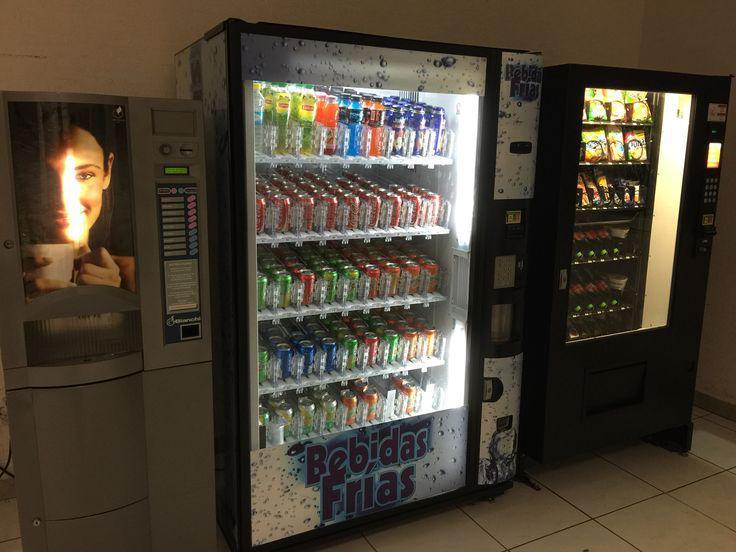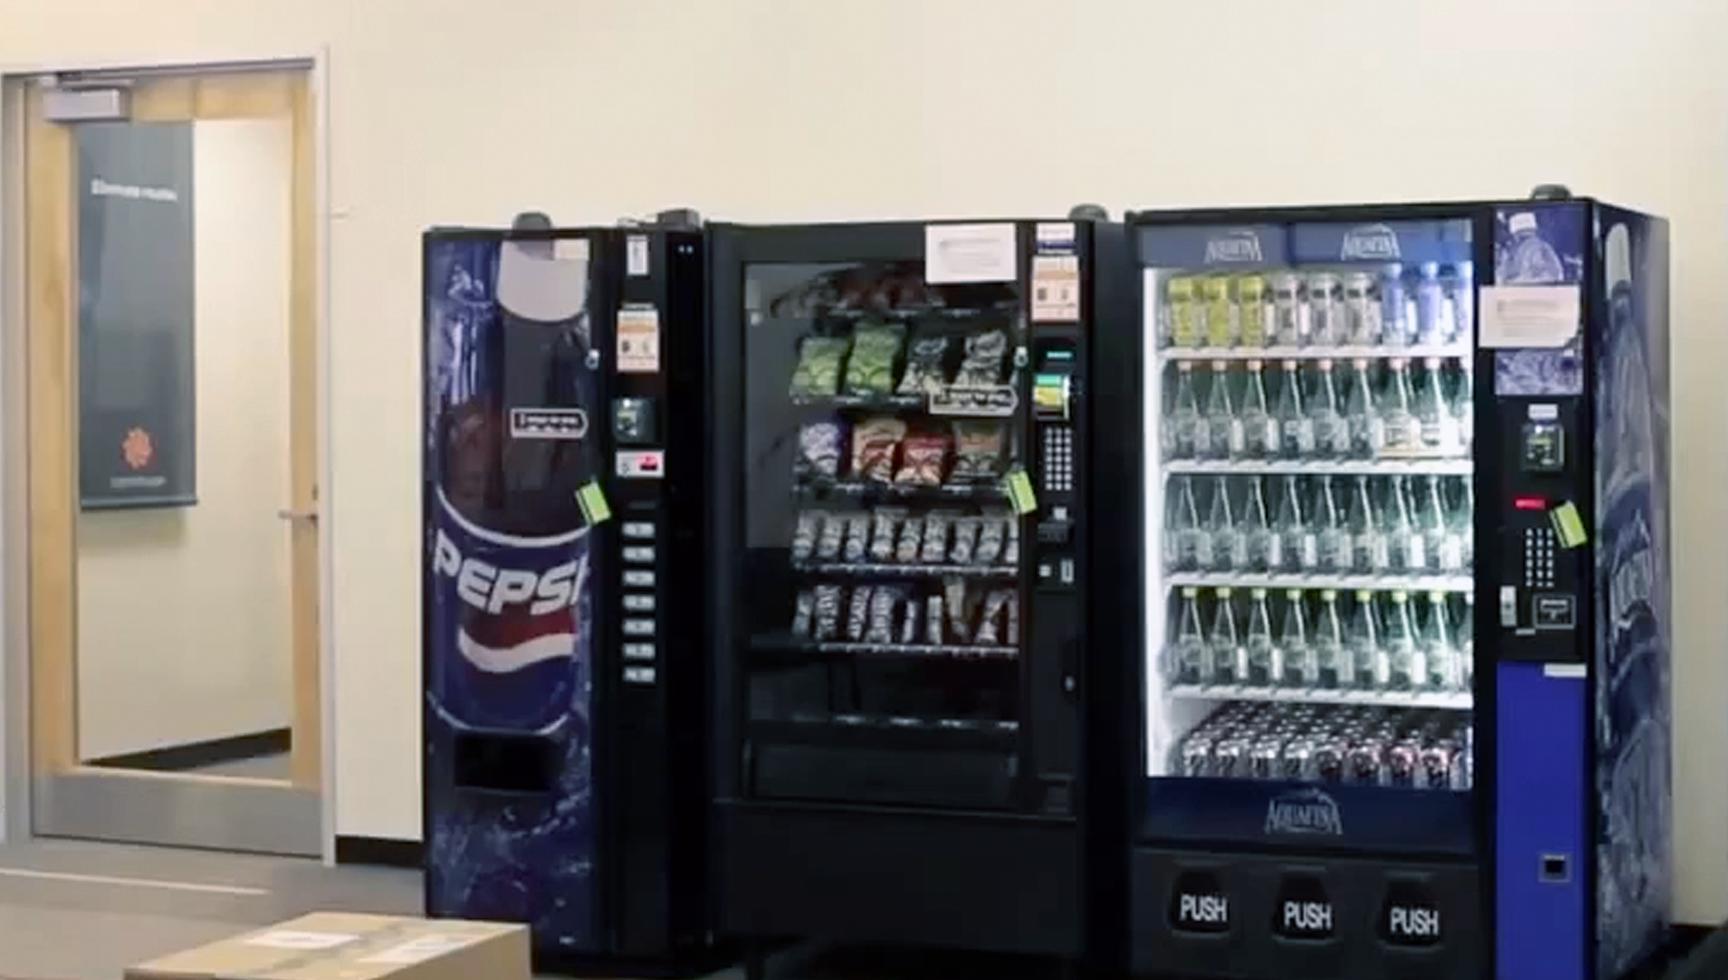The first image is the image on the left, the second image is the image on the right. For the images displayed, is the sentence "In one image, a row of three vending machines are the same height." factually correct? Answer yes or no. Yes. 